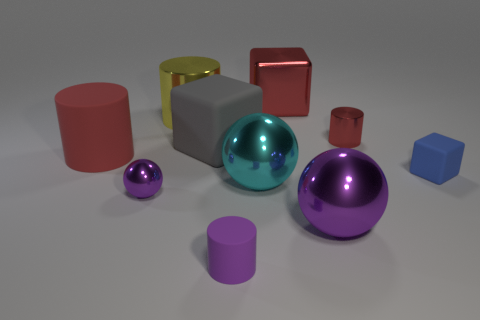Subtract all large shiny spheres. How many spheres are left? 1 Subtract all gray cubes. How many cubes are left? 2 Subtract all cylinders. How many objects are left? 6 Subtract 0 yellow cubes. How many objects are left? 10 Subtract 2 blocks. How many blocks are left? 1 Subtract all gray balls. Subtract all brown blocks. How many balls are left? 3 Subtract all red cubes. How many yellow cylinders are left? 1 Subtract all cyan metal things. Subtract all shiny cylinders. How many objects are left? 7 Add 6 cyan balls. How many cyan balls are left? 7 Add 5 blue rubber things. How many blue rubber things exist? 6 